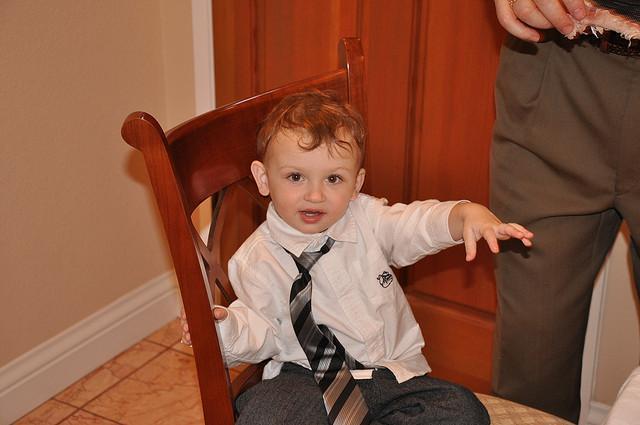How many hands are free?
Give a very brief answer. 1. 